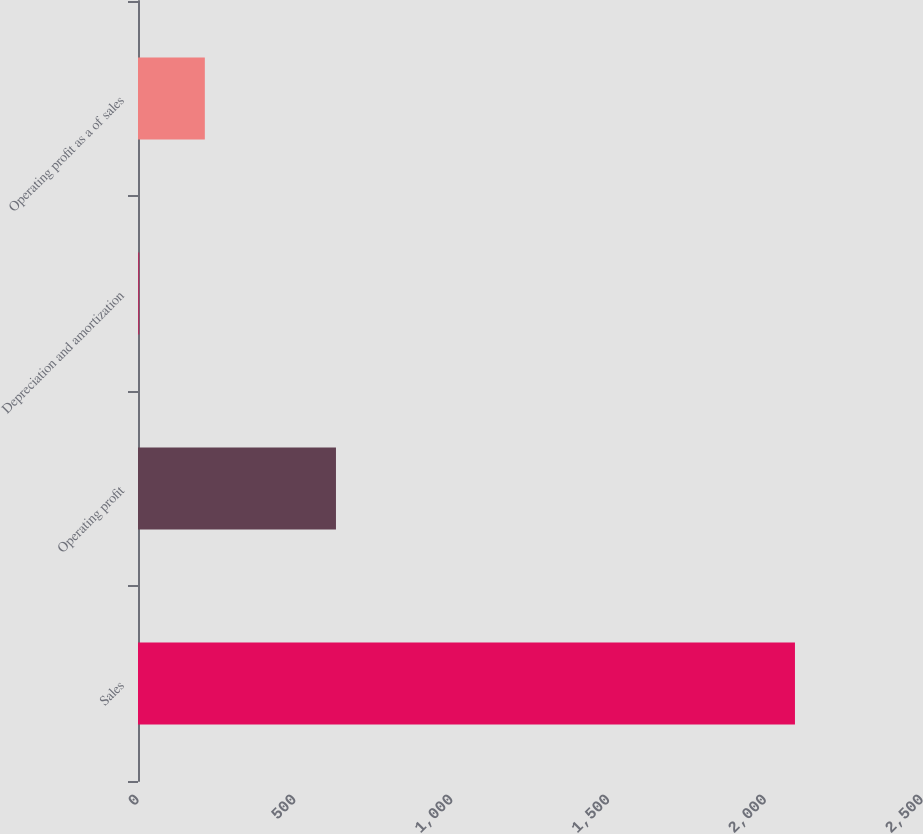<chart> <loc_0><loc_0><loc_500><loc_500><bar_chart><fcel>Sales<fcel>Operating profit<fcel>Depreciation and amortization<fcel>Operating profit as a of sales<nl><fcel>2094.9<fcel>631.27<fcel>4<fcel>213.09<nl></chart> 